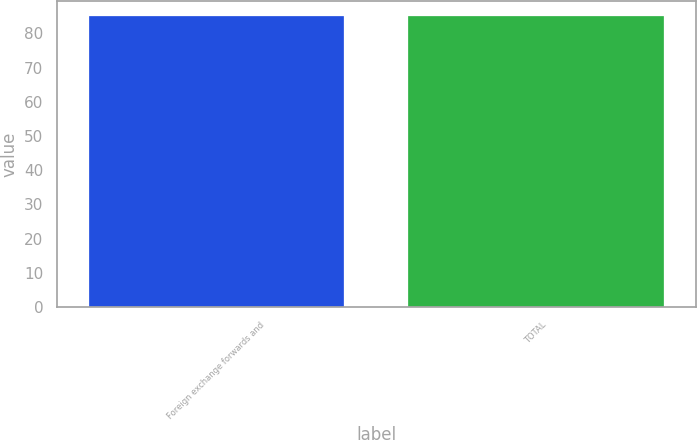Convert chart to OTSL. <chart><loc_0><loc_0><loc_500><loc_500><bar_chart><fcel>Foreign exchange forwards and<fcel>TOTAL<nl><fcel>85<fcel>85.1<nl></chart> 